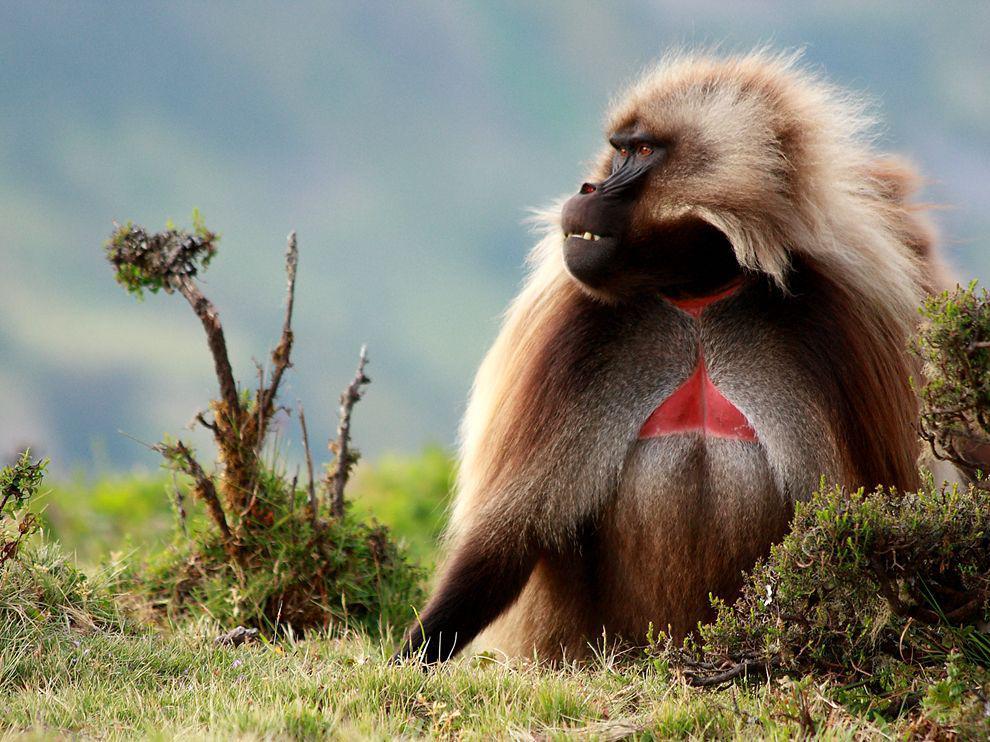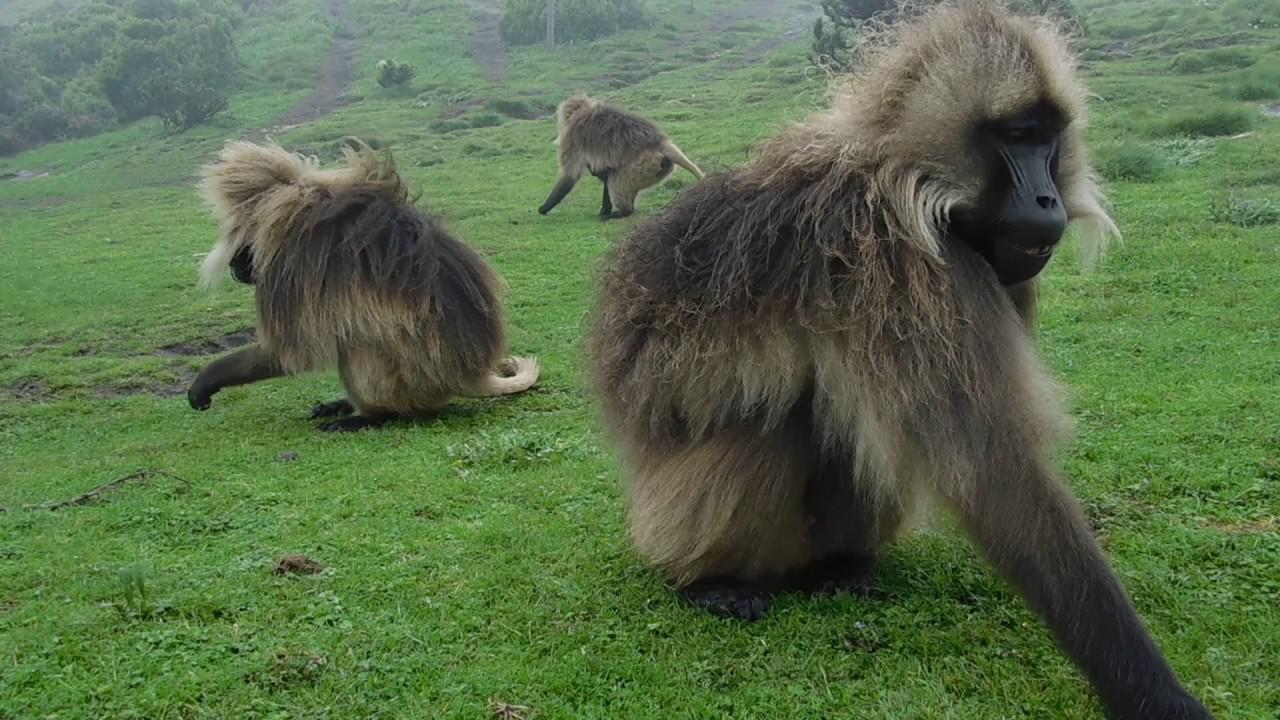The first image is the image on the left, the second image is the image on the right. Evaluate the accuracy of this statement regarding the images: "The left image contains exactly one baboon.". Is it true? Answer yes or no. Yes. The first image is the image on the left, the second image is the image on the right. Given the left and right images, does the statement "The right image shows monkeys crouching on the grass and reaching toward the ground, with no human in the foreground." hold true? Answer yes or no. Yes. 